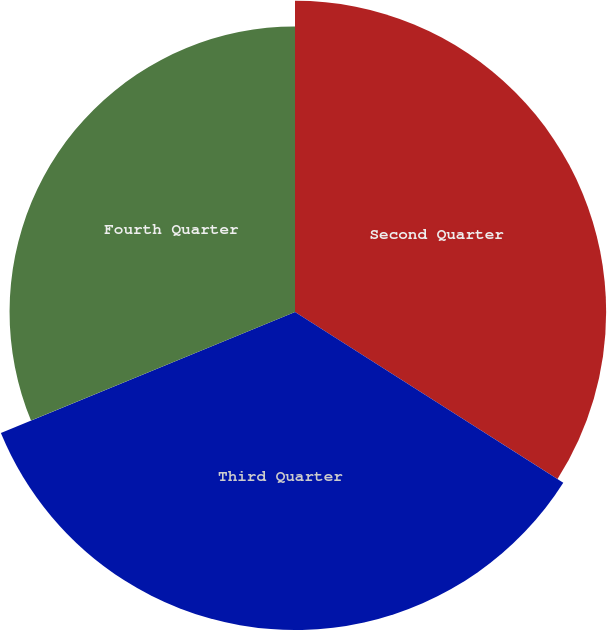<chart> <loc_0><loc_0><loc_500><loc_500><pie_chart><fcel>Second Quarter<fcel>Third Quarter<fcel>Fourth Quarter<nl><fcel>34.02%<fcel>34.77%<fcel>31.21%<nl></chart> 